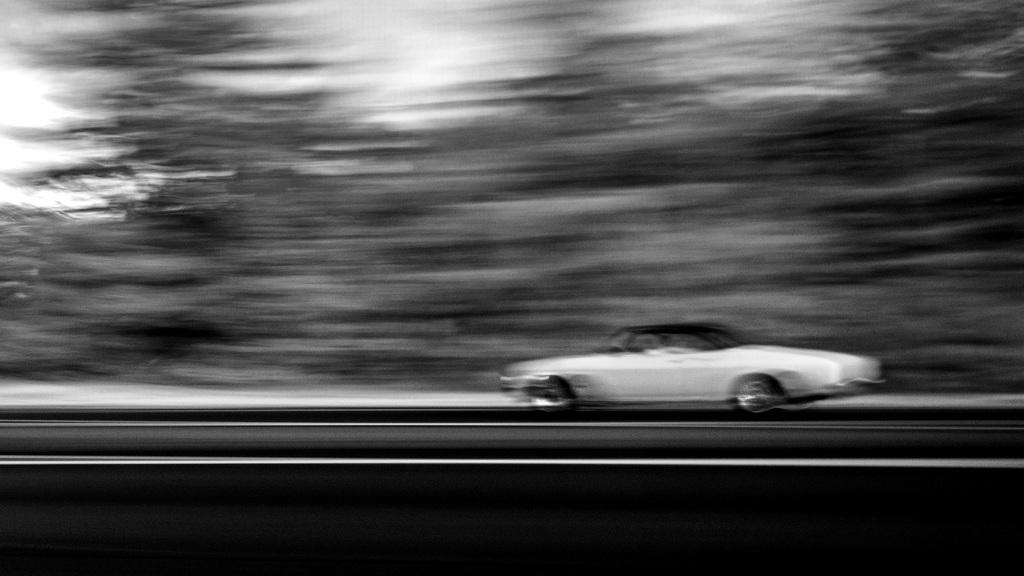What is the main subject of the image? There is a vehicle in the image. Where is the vehicle located? The vehicle is on the road. Can you describe the background of the image? The background of the image is blurry. How much wealth does the store in the image have? There is no store present in the image, so it is not possible to determine its wealth. 